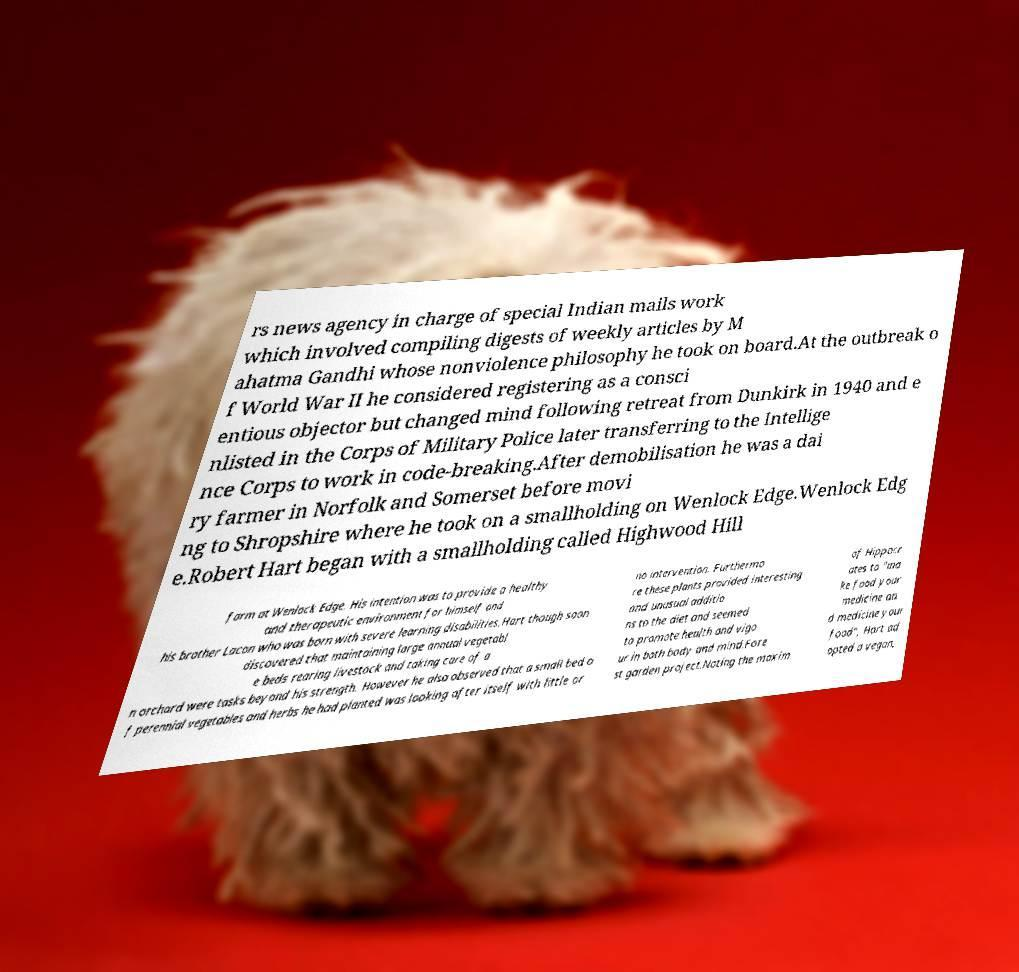Please identify and transcribe the text found in this image. rs news agency in charge of special Indian mails work which involved compiling digests of weekly articles by M ahatma Gandhi whose nonviolence philosophy he took on board.At the outbreak o f World War II he considered registering as a consci entious objector but changed mind following retreat from Dunkirk in 1940 and e nlisted in the Corps of Military Police later transferring to the Intellige nce Corps to work in code-breaking.After demobilisation he was a dai ry farmer in Norfolk and Somerset before movi ng to Shropshire where he took on a smallholding on Wenlock Edge.Wenlock Edg e.Robert Hart began with a smallholding called Highwood Hill farm at Wenlock Edge. His intention was to provide a healthy and therapeutic environment for himself and his brother Lacon who was born with severe learning disabilities.Hart though soon discovered that maintaining large annual vegetabl e beds rearing livestock and taking care of a n orchard were tasks beyond his strength. However he also observed that a small bed o f perennial vegetables and herbs he had planted was looking after itself with little or no intervention. Furthermo re these plants provided interesting and unusual additio ns to the diet and seemed to promote health and vigo ur in both body and mind.Fore st garden project.Noting the maxim of Hippocr ates to "ma ke food your medicine an d medicine your food", Hart ad opted a vegan, 